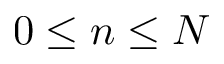Convert formula to latex. <formula><loc_0><loc_0><loc_500><loc_500>0 \leq n \leq N</formula> 